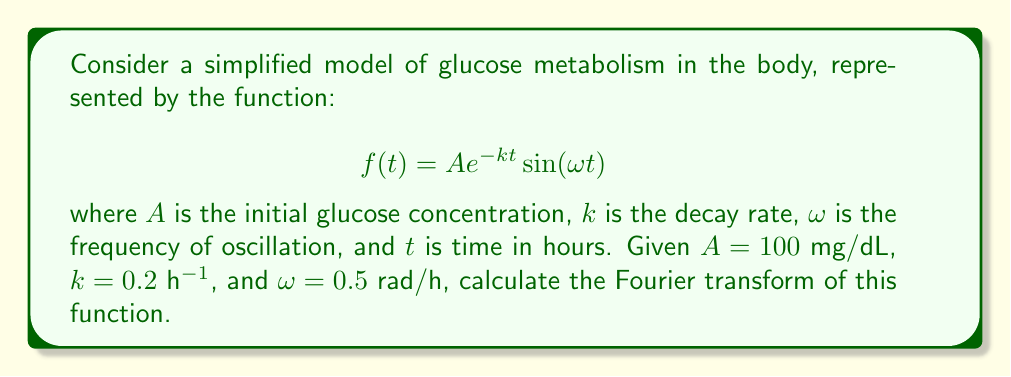Give your solution to this math problem. To calculate the Fourier transform of the given function, we'll follow these steps:

1) The Fourier transform of a function $f(t)$ is defined as:

   $$F(\xi) = \int_{-\infty}^{\infty} f(t) e^{-2\pi i \xi t} dt$$

2) Our function is:

   $$f(t) = 100 e^{-0.2t} \sin(0.5t)$$

3) We can rewrite the sine function using Euler's formula:

   $$\sin(0.5t) = \frac{e^{i0.5t} - e^{-i0.5t}}{2i}$$

4) Substituting this into our original function:

   $$f(t) = 100 e^{-0.2t} \cdot \frac{e^{i0.5t} - e^{-i0.5t}}{2i}$$

5) Now we can split this into two integrals:

   $$F(\xi) = \frac{100}{2i} \int_{-\infty}^{\infty} e^{-0.2t} e^{i0.5t} e^{-2\pi i \xi t} dt - \frac{100}{2i} \int_{-\infty}^{\infty} e^{-0.2t} e^{-i0.5t} e^{-2\pi i \xi t} dt$$

6) Simplifying the exponents:

   $$F(\xi) = \frac{100}{2i} \int_{-\infty}^{\infty} e^{-(0.2-i0.5+2\pi i \xi)t} dt - \frac{100}{2i} \int_{-\infty}^{\infty} e^{-(0.2+i0.5+2\pi i \xi)t} dt$$

7) The integral of $e^{-at}$ from $-\infty$ to $\infty$ is $\frac{2}{a}$ when the real part of $a$ is positive. In our case, this condition is met as the real part is 0.2. So:

   $$F(\xi) = \frac{100}{2i} \cdot \frac{2}{0.2-i0.5+2\pi i \xi} - \frac{100}{2i} \cdot \frac{2}{0.2+i0.5+2\pi i \xi}$$

8) Simplifying:

   $$F(\xi) = \frac{100}{0.2-i0.5+2\pi i \xi} - \frac{100}{0.2+i0.5+2\pi i \xi}$$

9) Finding a common denominator:

   $$F(\xi) = 100 \cdot \frac{(0.2+i0.5+2\pi i \xi) - (0.2-i0.5+2\pi i \xi)}{(0.2-i0.5+2\pi i \xi)(0.2+i0.5+2\pi i \xi)}$$

10) Simplifying the numerator:

    $$F(\xi) = 100 \cdot \frac{2i0.5}{(0.2-i0.5+2\pi i \xi)(0.2+i0.5+2\pi i \xi)}$$

11) Final simplification:

    $$F(\xi) = \frac{100i}{(0.2-i0.5+2\pi i \xi)(0.2+i0.5+2\pi i \xi)}$$

This is the Fourier transform of the given function.
Answer: $$F(\xi) = \frac{100i}{(0.2-i0.5+2\pi i \xi)(0.2+i0.5+2\pi i \xi)}$$ 